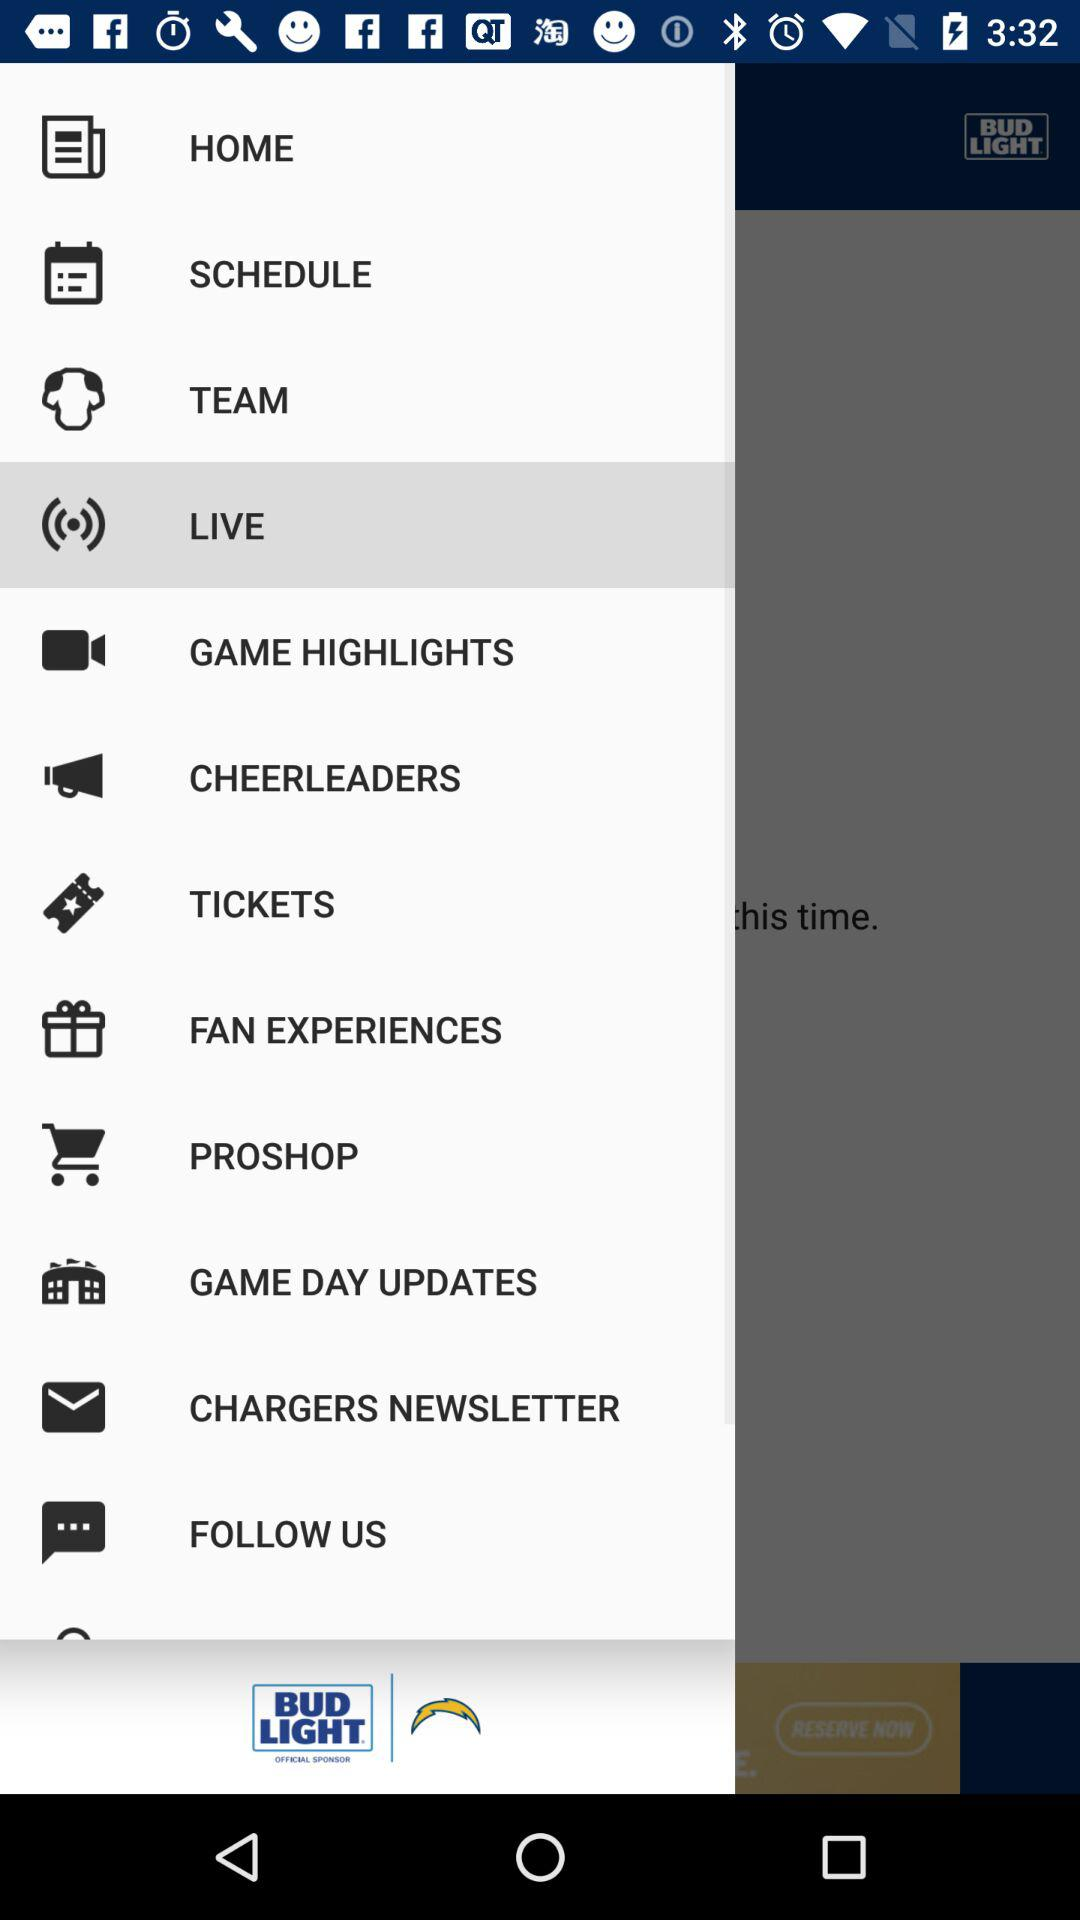Which item is selected? The selected item is "LIVE". 